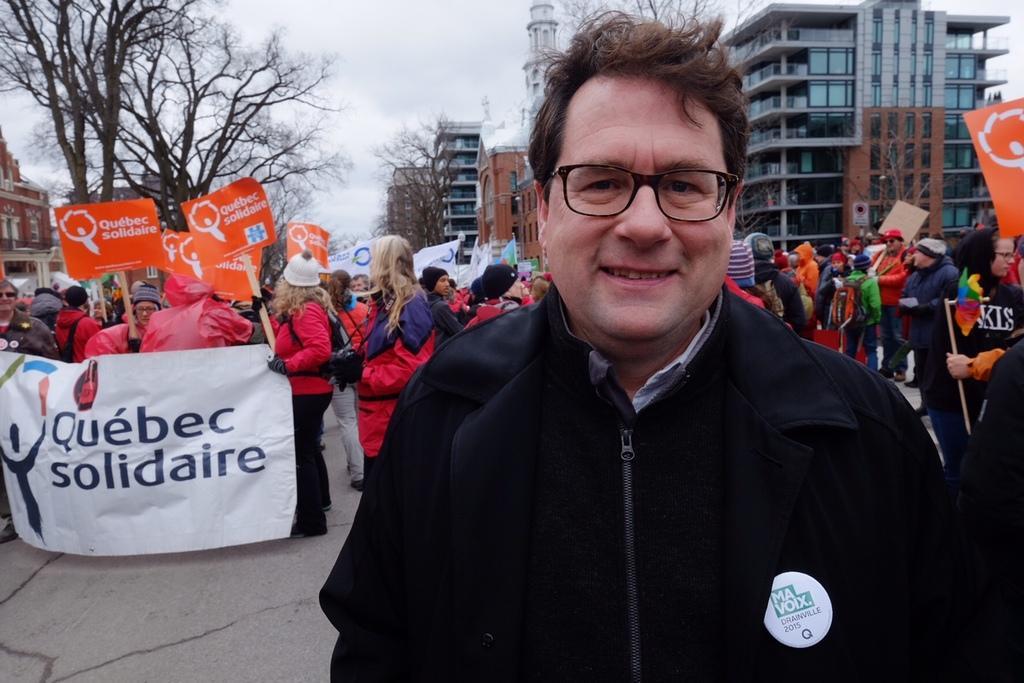In one or two sentences, can you explain what this image depicts? In the foreground of this image, we see a man in black dress having smile on his face. In the background, there is the crowd with pluck cards and banners in their hands and on top, we see buildings trees and the sky. 